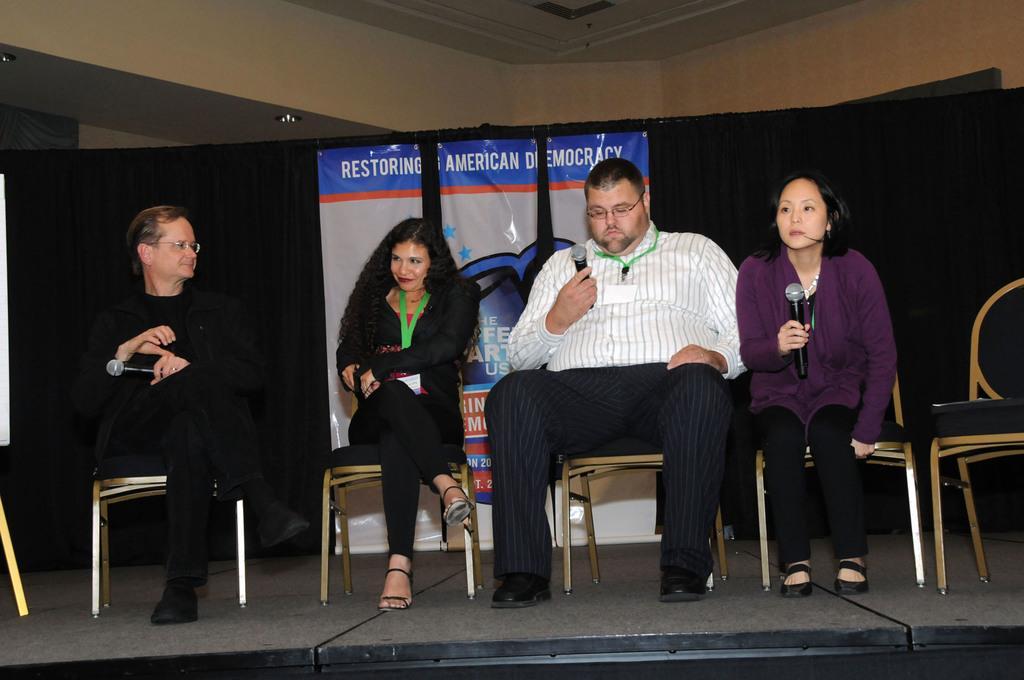Can you describe this image briefly? In this image, we can see persons wearing clothes and sitting on chairs. There are some persons holding mics with their hands. There is chair on the right side of the image. There is a banner in the middle of the image. There is ceiling at the top of the image. 